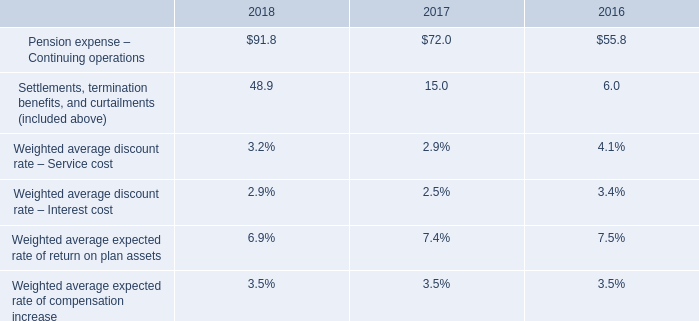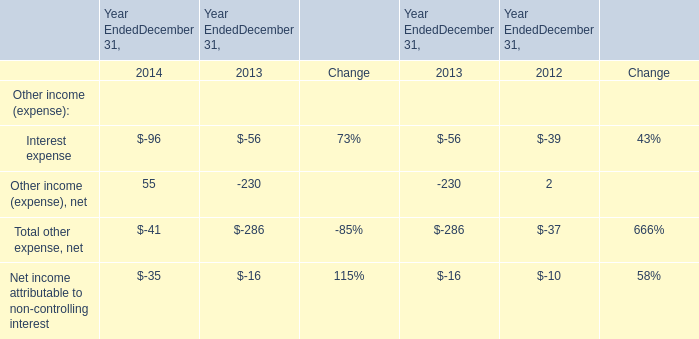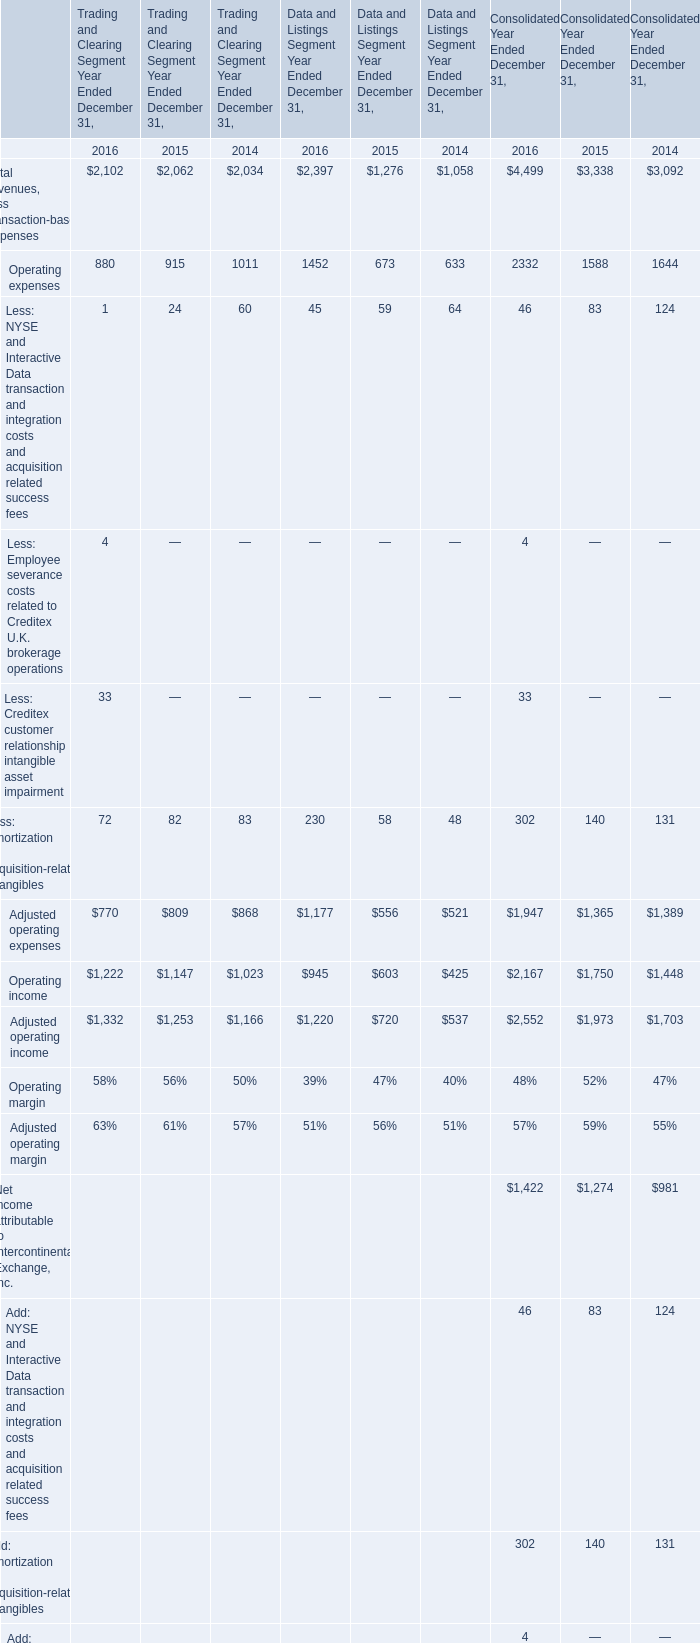In which year is Operating income for Trading and Clearing Segment Year Ended December 31 greater than 2100? 
Answer: 2016. 